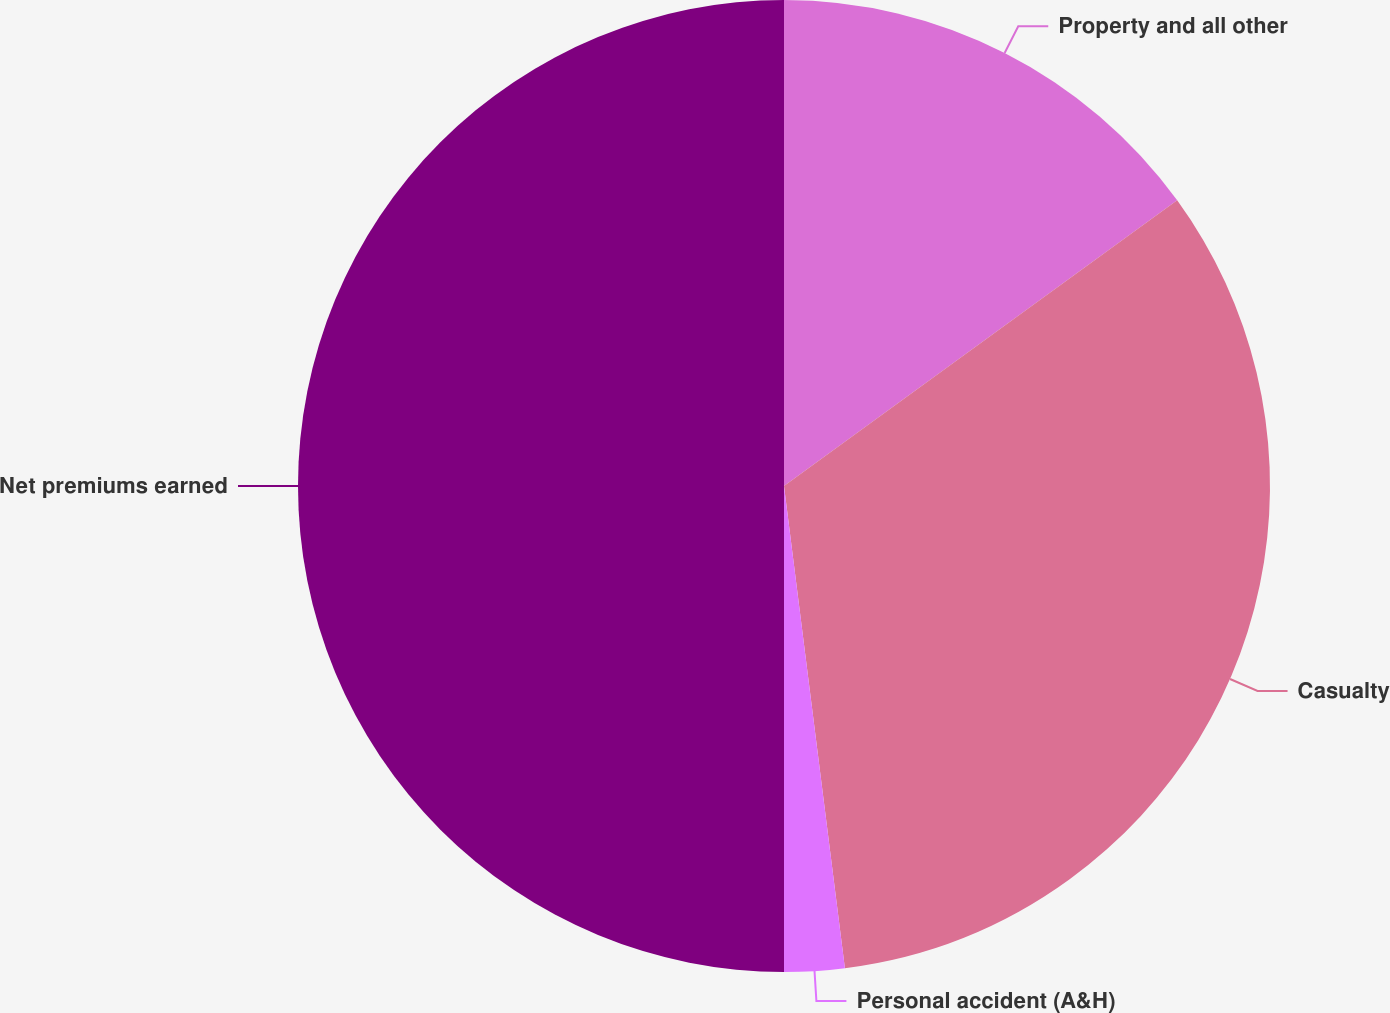Convert chart. <chart><loc_0><loc_0><loc_500><loc_500><pie_chart><fcel>Property and all other<fcel>Casualty<fcel>Personal accident (A&H)<fcel>Net premiums earned<nl><fcel>15.0%<fcel>33.0%<fcel>2.0%<fcel>50.0%<nl></chart> 